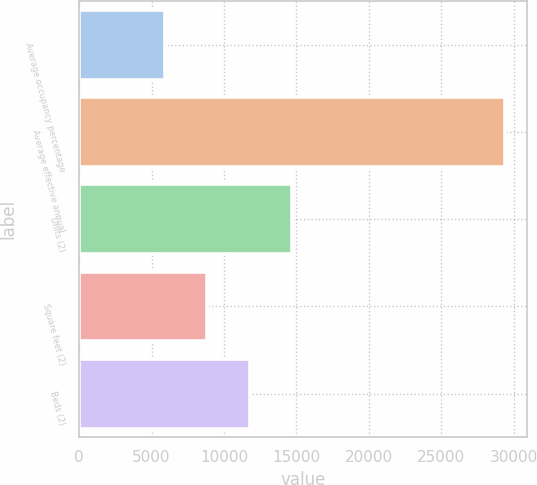Convert chart. <chart><loc_0><loc_0><loc_500><loc_500><bar_chart><fcel>Average occupancy percentage<fcel>Average effective annual<fcel>Units (2)<fcel>Square feet (2)<fcel>Beds (2)<nl><fcel>5900.8<fcel>29420<fcel>14720.5<fcel>8840.7<fcel>11780.6<nl></chart> 